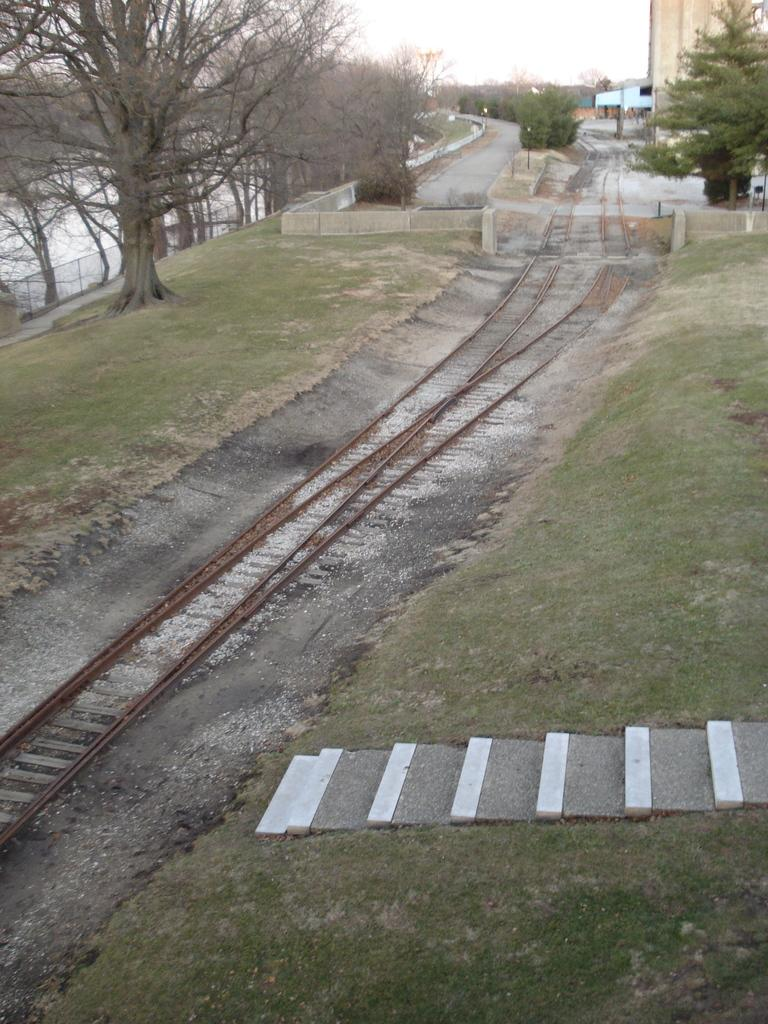What type of transportation infrastructure is present in the image? There is a railway track in the image. What architectural feature can be seen in the image? There is a staircase in the image. What type of structure is visible in the image? There is a building in the image. What can be seen in the background of the image? There is a group of trees and a fence in the background of the image, along with the sky. What type of payment method is being used by the mother in the image? There is no mother present in the image, so it is not possible to determine what payment method she might be using. What type of iron is visible in the image? There is no iron present in the image. 